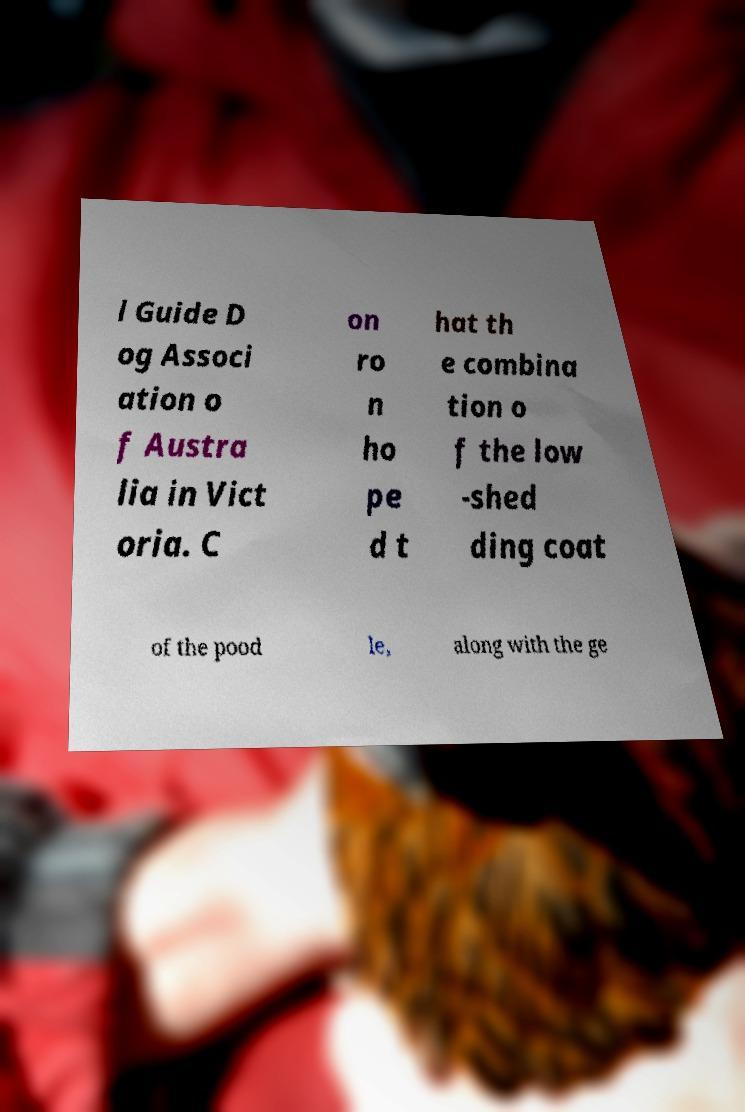For documentation purposes, I need the text within this image transcribed. Could you provide that? l Guide D og Associ ation o f Austra lia in Vict oria. C on ro n ho pe d t hat th e combina tion o f the low -shed ding coat of the pood le, along with the ge 